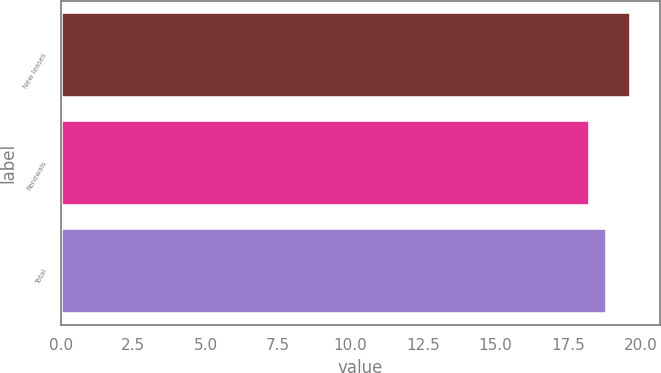<chart> <loc_0><loc_0><loc_500><loc_500><bar_chart><fcel>New leases<fcel>Renewals<fcel>Total<nl><fcel>19.68<fcel>18.27<fcel>18.86<nl></chart> 